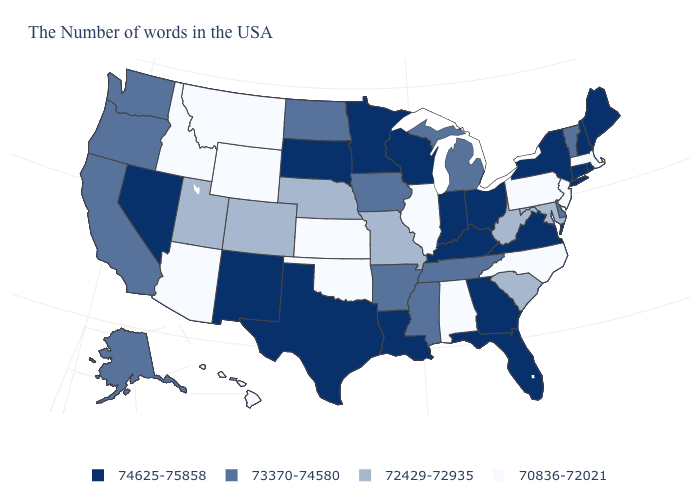What is the value of Maryland?
Keep it brief. 72429-72935. How many symbols are there in the legend?
Quick response, please. 4. What is the lowest value in the USA?
Keep it brief. 70836-72021. Name the states that have a value in the range 72429-72935?
Concise answer only. Maryland, South Carolina, West Virginia, Missouri, Nebraska, Colorado, Utah. Among the states that border Florida , does Georgia have the highest value?
Quick response, please. Yes. Does the first symbol in the legend represent the smallest category?
Keep it brief. No. Does Connecticut have the same value as Virginia?
Write a very short answer. Yes. What is the value of Washington?
Concise answer only. 73370-74580. What is the lowest value in the USA?
Answer briefly. 70836-72021. Does South Carolina have a lower value than Arizona?
Concise answer only. No. Which states have the highest value in the USA?
Give a very brief answer. Maine, Rhode Island, New Hampshire, Connecticut, New York, Virginia, Ohio, Florida, Georgia, Kentucky, Indiana, Wisconsin, Louisiana, Minnesota, Texas, South Dakota, New Mexico, Nevada. What is the value of Wyoming?
Keep it brief. 70836-72021. Does Florida have the lowest value in the USA?
Give a very brief answer. No. What is the value of Pennsylvania?
Write a very short answer. 70836-72021. What is the value of Alabama?
Answer briefly. 70836-72021. 